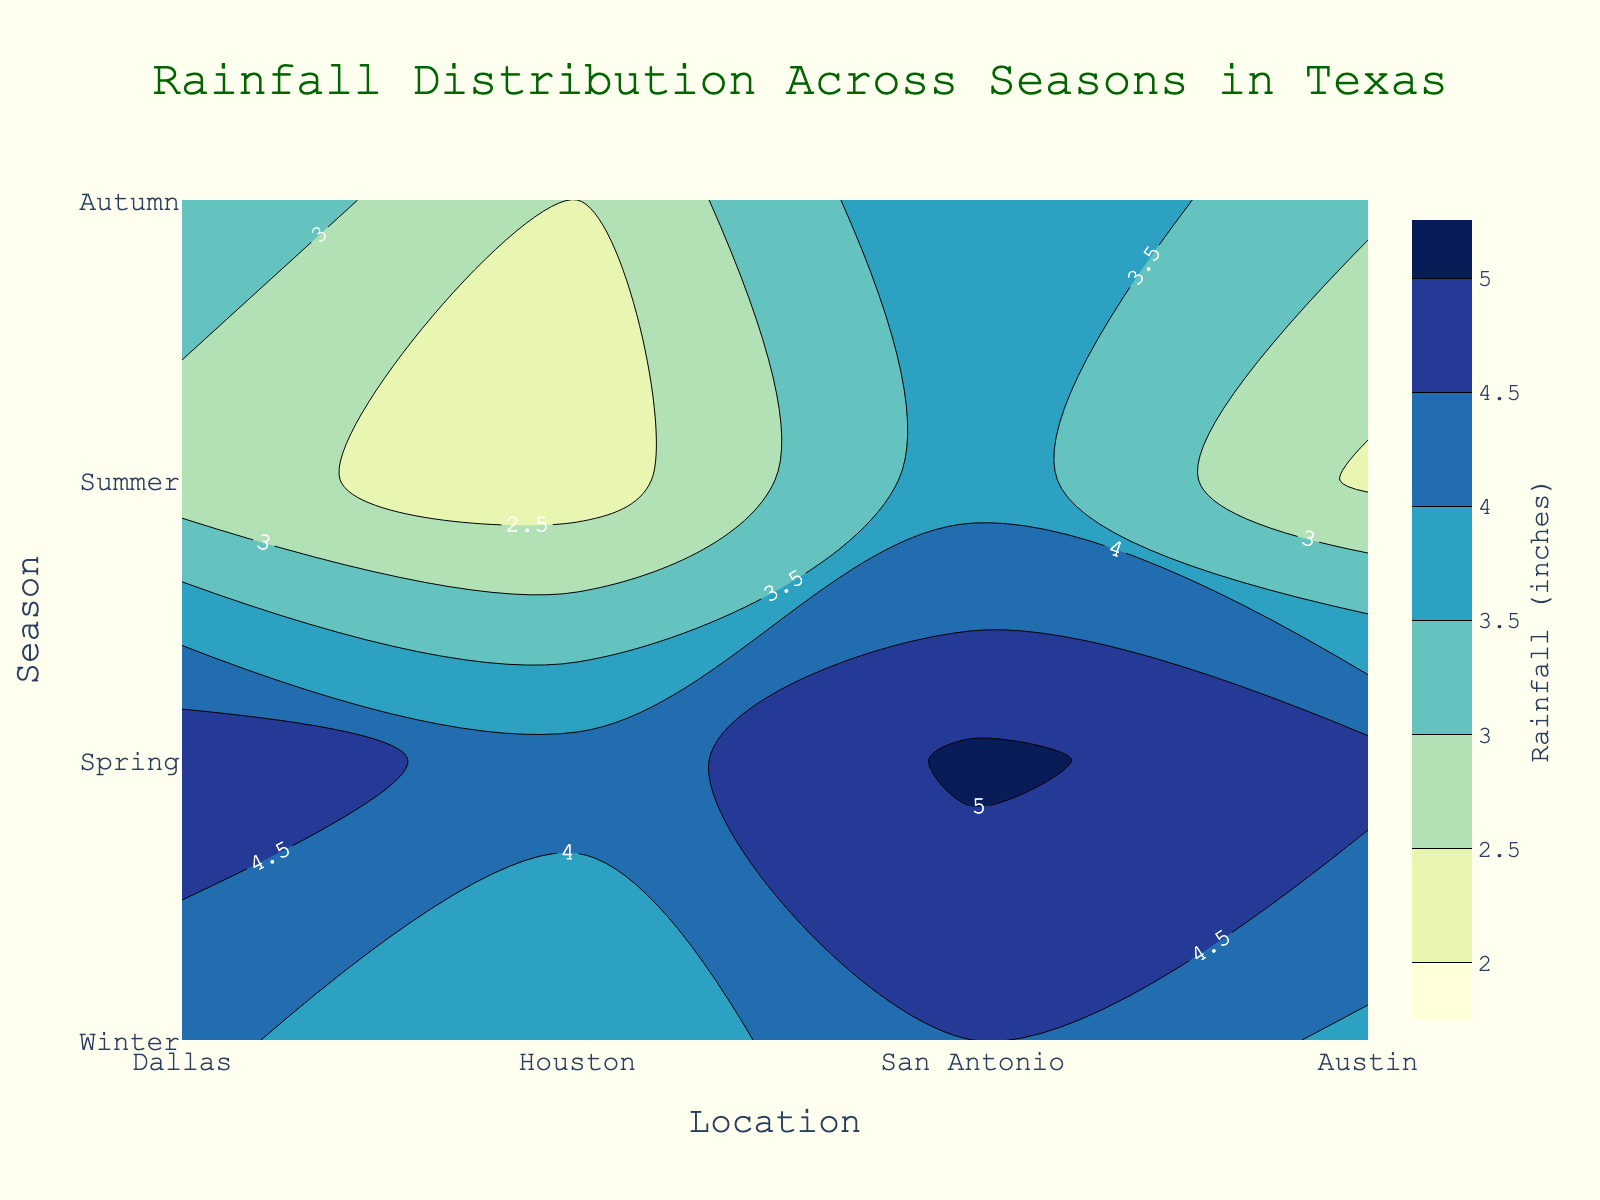What is the title of the plot? The title of the plot is usually located at the top center of the figure and provides an overall description of what the plot represents. The title in this case is "Rainfall Distribution Across Seasons in Texas."
Answer: Rainfall Distribution Across Seasons in Texas What are the units for the rainfall measurements? The units for the rainfall measurements are typically indicated in the color bar or axis label. Here, it is clearly mentioned as "inches" in the color bar title "Rainfall (inches)."
Answer: inches Which season has the highest average rainfall across all locations? To find the season with the highest average rainfall, we need to average the rainfall values for each season. Spring has the highest values ([4.2, 5.1, 4.7, 4.9]), with an average of (4.2 + 5.1 + 4.7 + 4.9) / 4 = 4.725 inches.
Answer: Spring What is the range of rainfall values represented in the contour plot? The range is typically defined by the contour settings. Here, the contour lines start at 2 inches and end at 5 inches, as seen in the color scale and labels.
Answer: 2 to 5 inches Which location receives the least rainfall in summer? To determine the location with the least rainfall in summer, we examine the summer row: Dallas (2.2), Houston (3.8), San Antonio (2.4), Austin (2.7). Dallas has the lowest value at 2.2 inches.
Answer: Dallas How does rainfall in Houston vary between the winter and summer seasons? We need to compare the values for Houston in both seasons. Winter has 4.0 inches, and summer has 3.8 inches. The difference is 4.0 - 3.8 = 0.2 inches, with more rainfall in winter.
Answer: 0.2 inches more in winter Which season has the most variation in rainfall across all locations? To find the season with the most variation, we calculate the range (max - min) for each season. Winter: 4.0 - 2.5 = 1.5; Spring: 5.1 - 4.2 = 0.9; Summer: 3.8 - 2.2 = 1.6; Autumn: 4.5 - 3.6 = 0.9. Summer has the most variation with 1.6 inches.
Answer: Summer What color represents the highest rainfall in the contour plot? In contour plots, colors correspond to different value ranges, indicated by the color bar. The highest rainfall value (5 inches) is represented by the darkest shade at the higher end of the 'YlGnBu' color scale, typically dark blue.
Answer: Dark blue Which location has the most consistent rainfall across all seasons? To find the most consistent rainfall, we calculate the range (max - min) for each location. Dallas: 4.2 - 2.2 = 2.0; Houston: 5.1 - 3.8 = 1.3; San Antonio: 4.7 - 2.4 = 2.3; Austin: 4.9 - 2.7 = 2.2. Houston has the smallest range at 1.3 inches.
Answer: Houston 